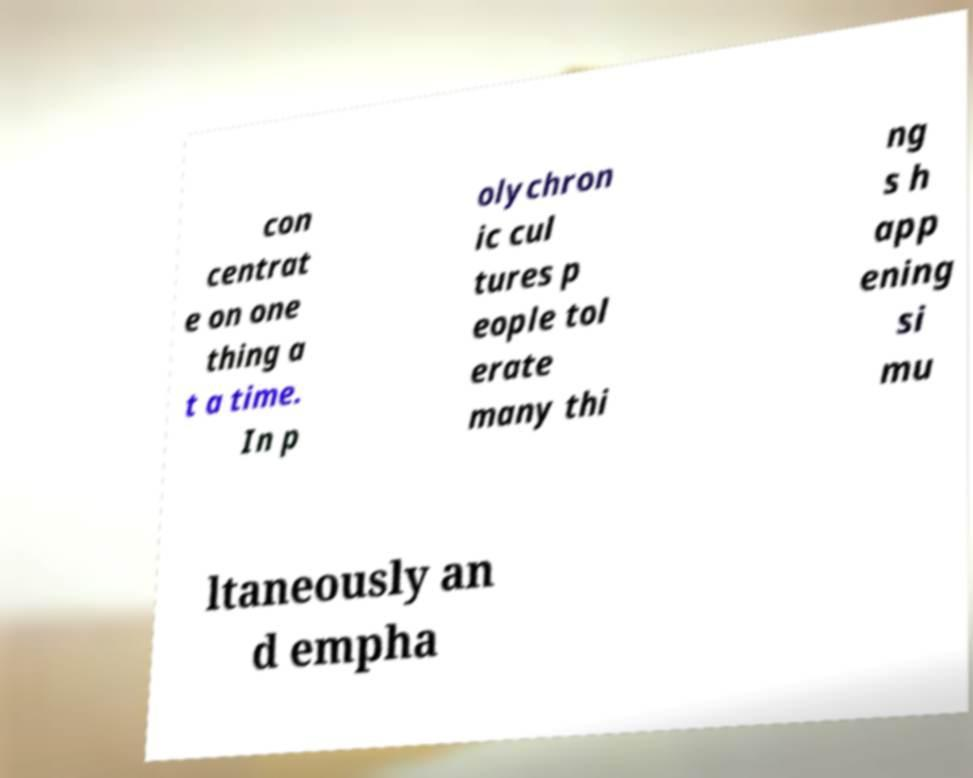Can you read and provide the text displayed in the image?This photo seems to have some interesting text. Can you extract and type it out for me? con centrat e on one thing a t a time. In p olychron ic cul tures p eople tol erate many thi ng s h app ening si mu ltaneously an d empha 